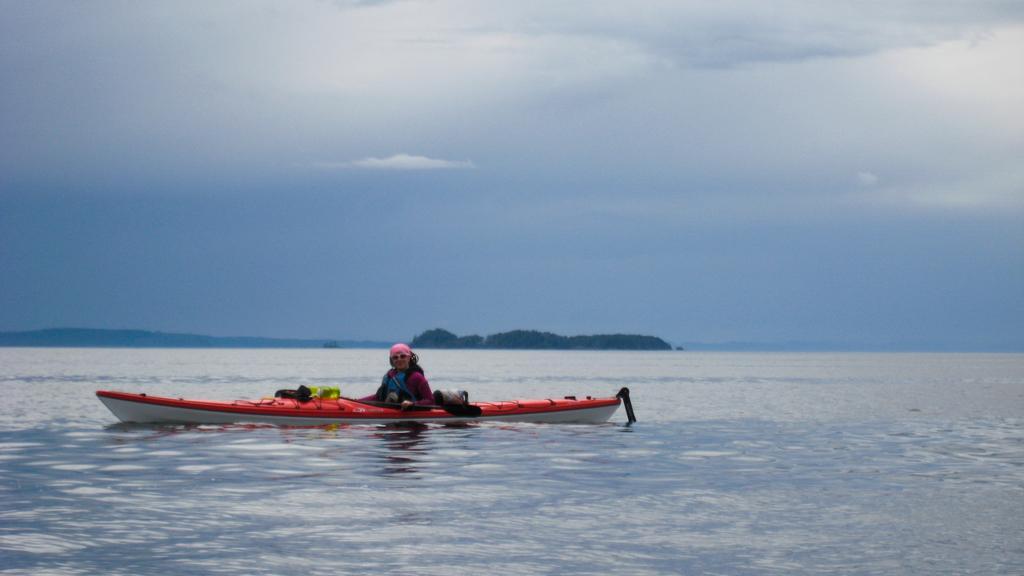In one or two sentences, can you explain what this image depicts? In this picture I can observe sea kayak in the middle of the picture. There is a person in the sea kayak. In the background I can observe an ocean and sky. 